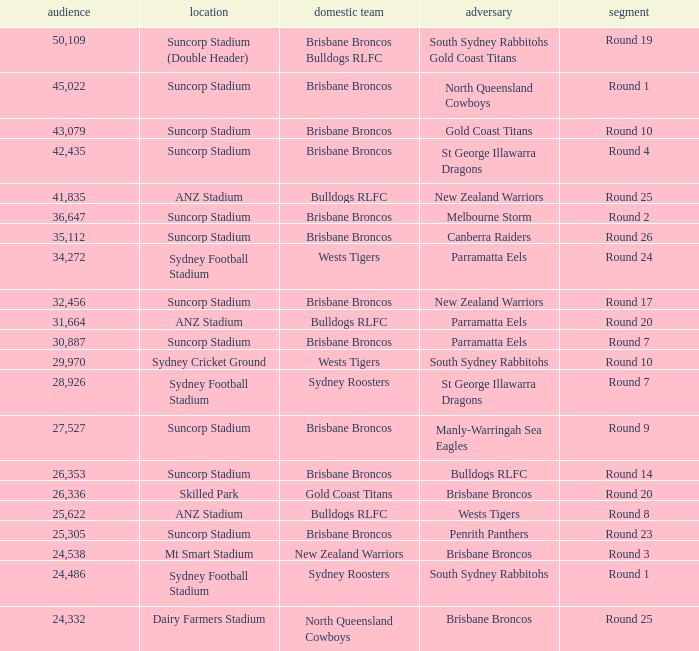What was the attendance at Round 9? 1.0. 